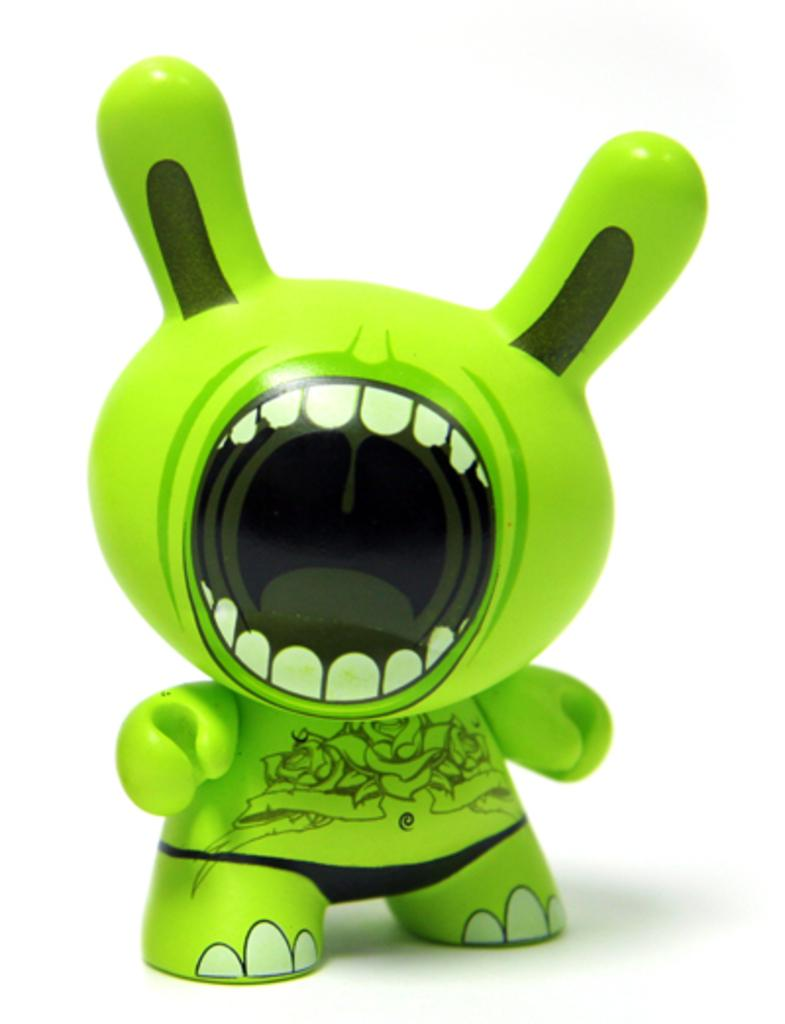What type of object is the main subject in the image? There is a green toy in the image. What color is the toy? The toy is green. What can be seen in the background of the image? The background of the image is white. What type of pie is being pushed in the image? There is no pie or pushing action present in the image; it features a green toy against a white background. 